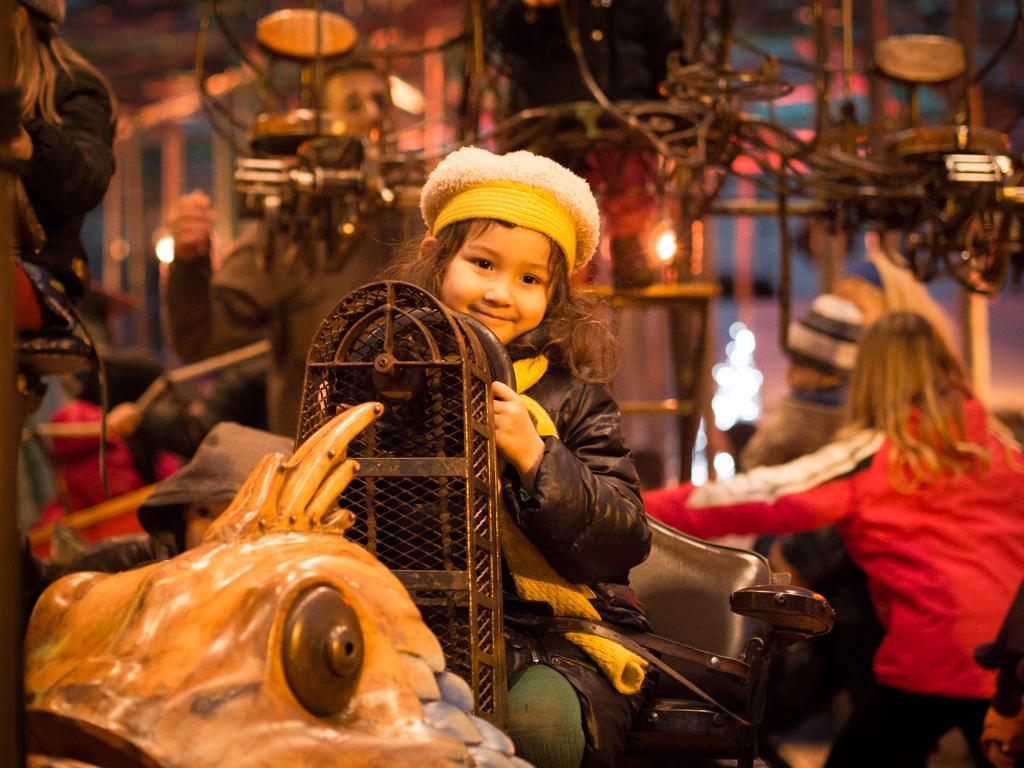How would you summarize this image in a sentence or two? In this image, its look like an amusement kids riding on which there are few kids riding and there is a person. The background is not clear. 